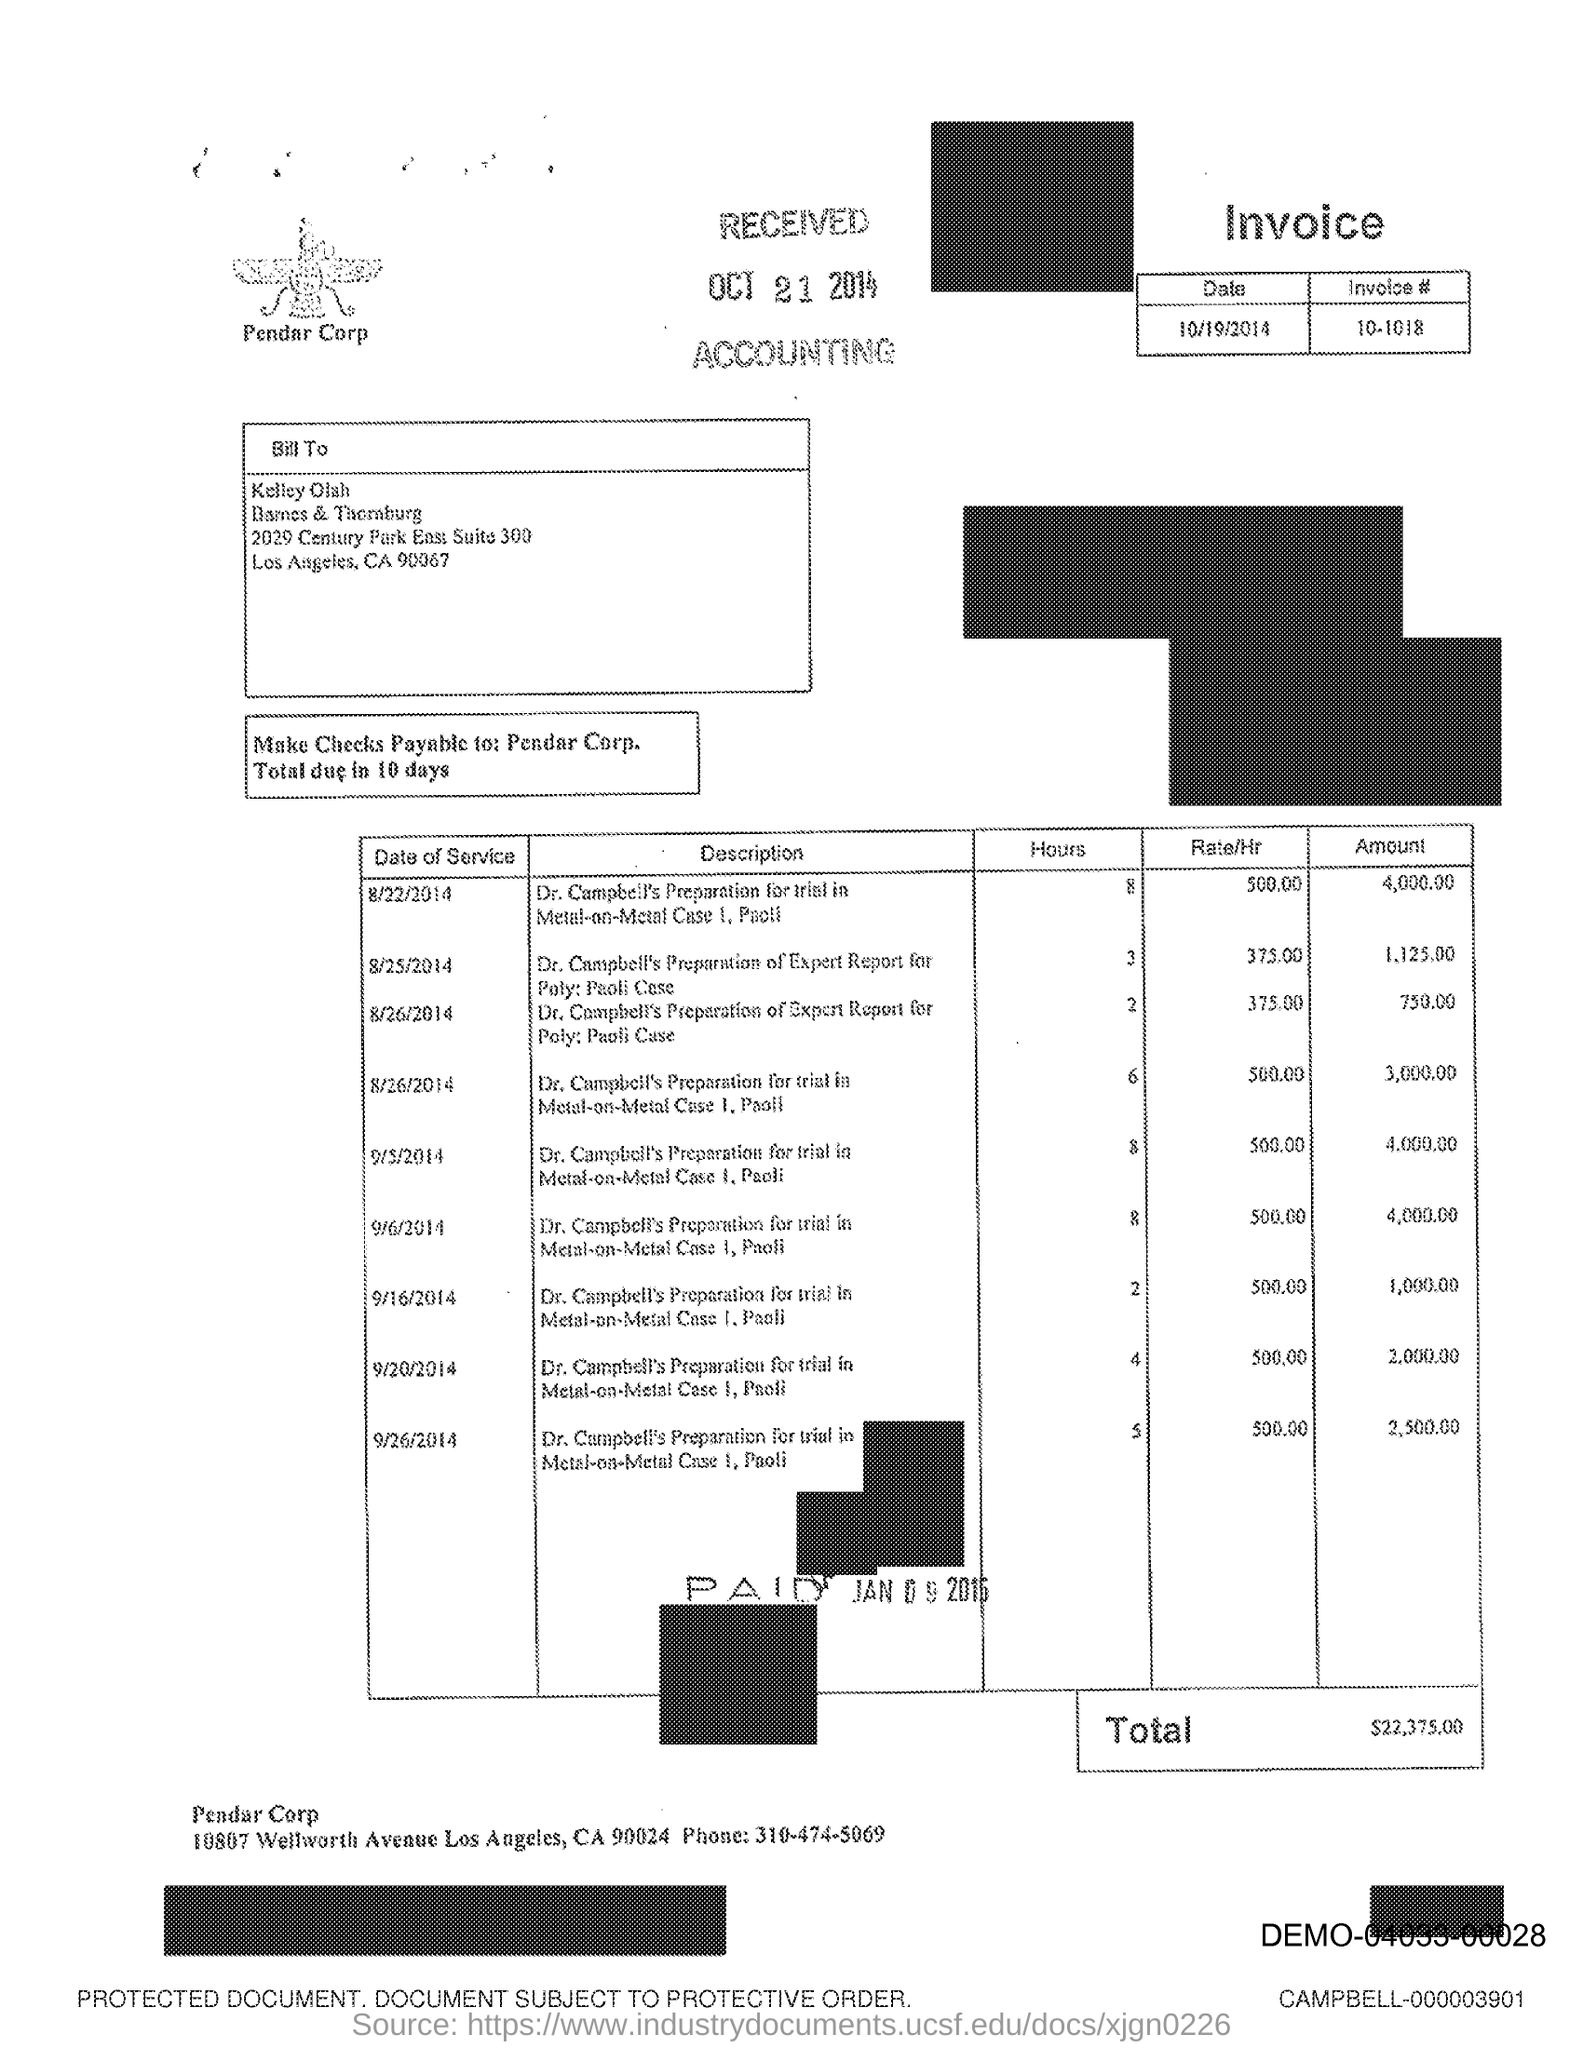What is the phone number mentioned in the document?
Provide a short and direct response. 310-474-5069. 